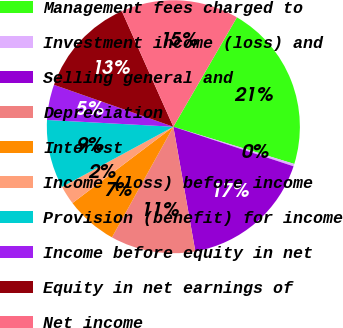<chart> <loc_0><loc_0><loc_500><loc_500><pie_chart><fcel>Management fees charged to<fcel>Investment income (loss) and<fcel>Selling general and<fcel>Depreciation<fcel>Interest<fcel>Income (loss) before income<fcel>Provision (benefit) for income<fcel>Income before equity in net<fcel>Equity in net earnings of<fcel>Net income<nl><fcel>21.37%<fcel>0.31%<fcel>17.16%<fcel>10.84%<fcel>6.63%<fcel>2.42%<fcel>8.74%<fcel>4.52%<fcel>12.95%<fcel>15.05%<nl></chart> 